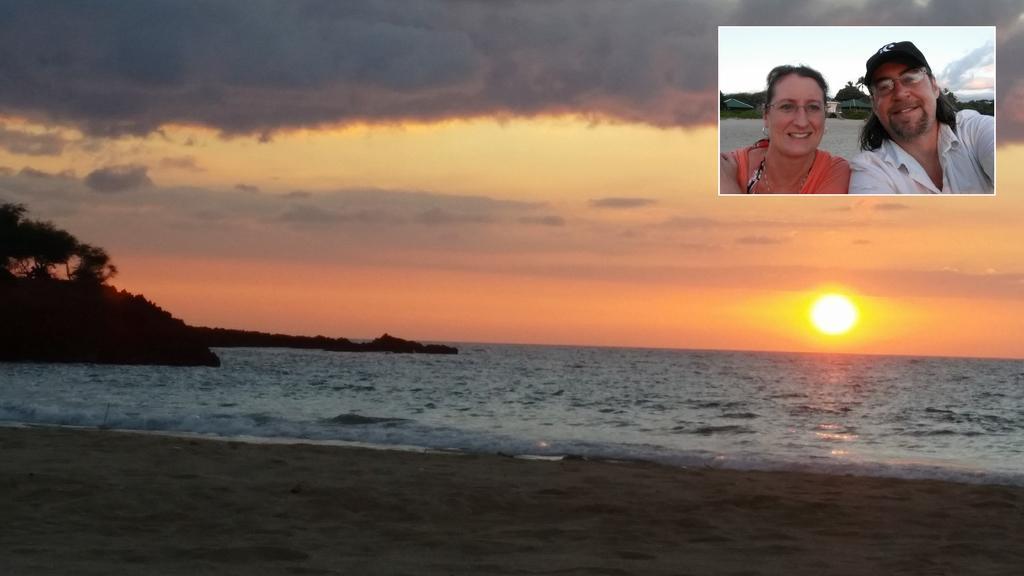How would you summarize this image in a sentence or two? In this image, we can see water, few trees and sun. Background there is a cloudy sky. At the bottom, we can see sand. In the right top corner, there is an image of woman and man. They are smiling and wore spectacles. Background there are few trees and sky. 